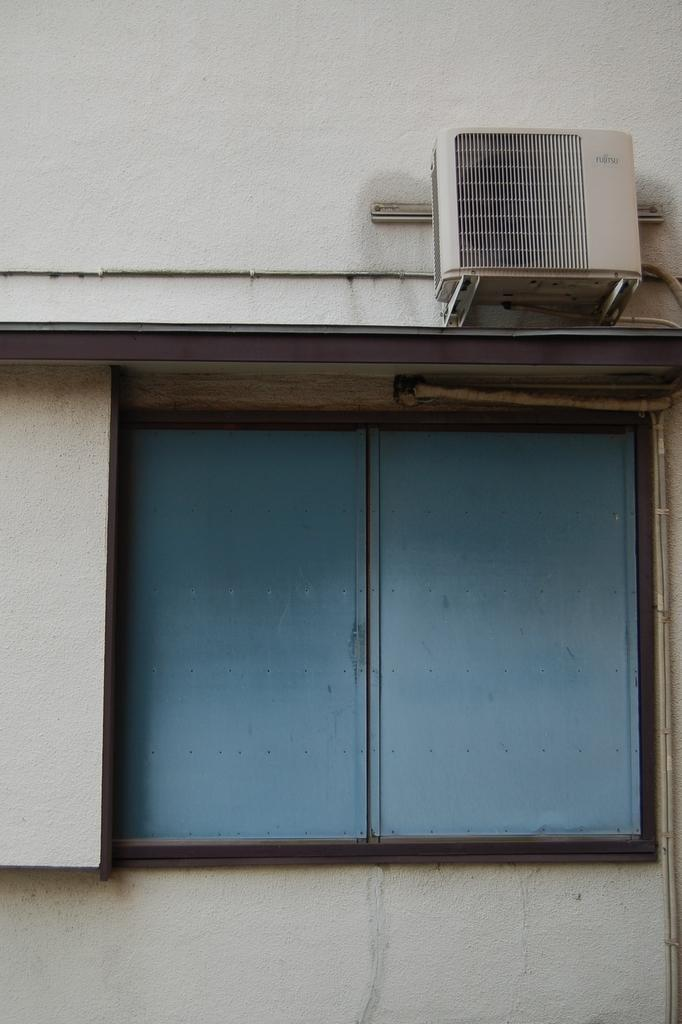What can be seen in the image that provides a view of the outside? There is a window in the image. What device is present in the background of the image to help regulate temperature? There is an air conditioner on the wall in the background of the image. What type of mint is growing on the twig outside the window in the image? There is no mention of mint or a twig in the image; it only features a window and an air conditioner on the wall. 